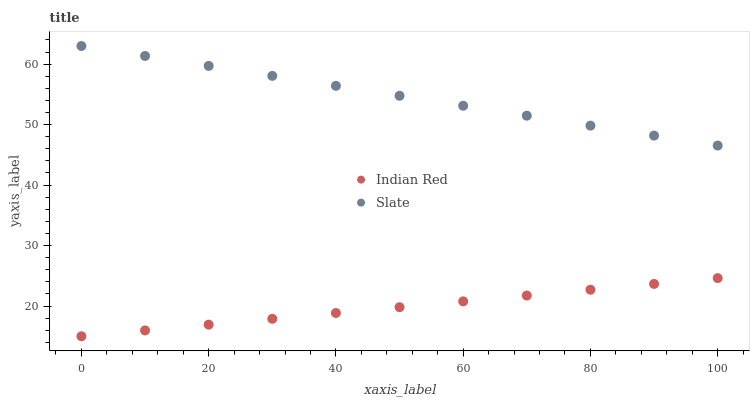Does Indian Red have the minimum area under the curve?
Answer yes or no. Yes. Does Slate have the maximum area under the curve?
Answer yes or no. Yes. Does Indian Red have the maximum area under the curve?
Answer yes or no. No. Is Indian Red the smoothest?
Answer yes or no. Yes. Is Slate the roughest?
Answer yes or no. Yes. Is Indian Red the roughest?
Answer yes or no. No. Does Indian Red have the lowest value?
Answer yes or no. Yes. Does Slate have the highest value?
Answer yes or no. Yes. Does Indian Red have the highest value?
Answer yes or no. No. Is Indian Red less than Slate?
Answer yes or no. Yes. Is Slate greater than Indian Red?
Answer yes or no. Yes. Does Indian Red intersect Slate?
Answer yes or no. No. 